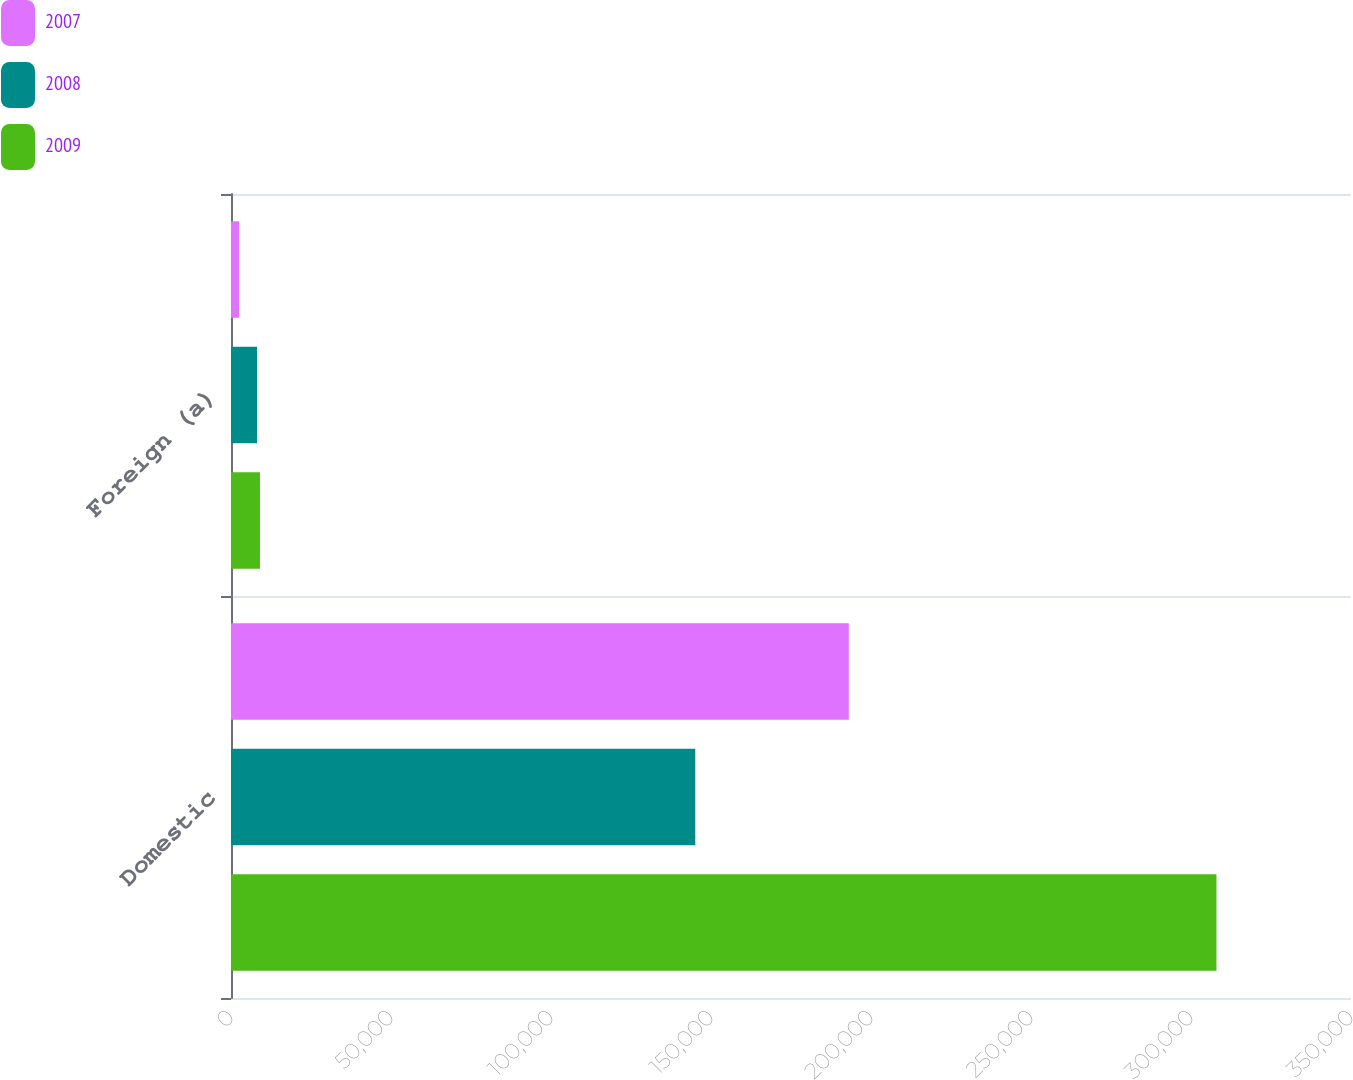<chart> <loc_0><loc_0><loc_500><loc_500><stacked_bar_chart><ecel><fcel>Domestic<fcel>Foreign (a)<nl><fcel>2007<fcel>193055<fcel>2532<nl><fcel>2008<fcel>145086<fcel>8133<nl><fcel>2009<fcel>307953<fcel>9050<nl></chart> 